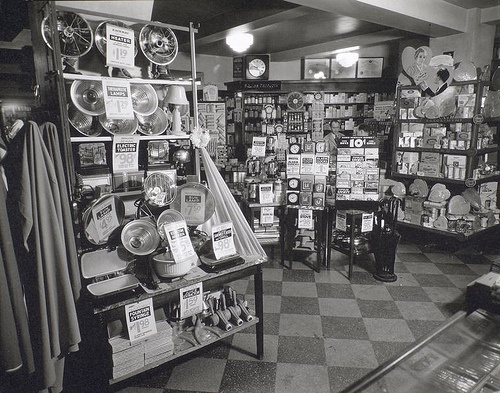Describe the objects in this image and their specific colors. I can see clock in black, gray, darkgray, and lightgray tones, clock in black, gray, darkgray, and lightgray tones, bowl in black, gray, darkgray, and lightgray tones, clock in black, lightgray, darkgray, and gray tones, and clock in black and gray tones in this image. 